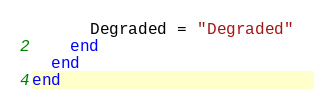Convert code to text. <code><loc_0><loc_0><loc_500><loc_500><_Ruby_>      Degraded = "Degraded"
    end
  end
end
</code> 